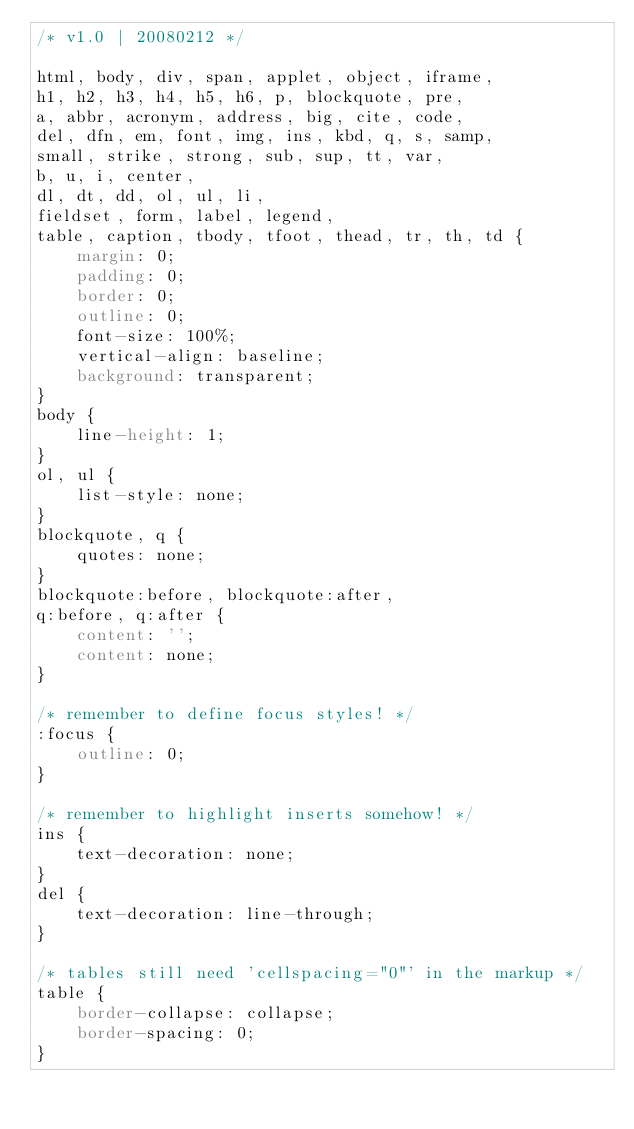Convert code to text. <code><loc_0><loc_0><loc_500><loc_500><_CSS_>/* v1.0 | 20080212 */

html, body, div, span, applet, object, iframe,
h1, h2, h3, h4, h5, h6, p, blockquote, pre,
a, abbr, acronym, address, big, cite, code,
del, dfn, em, font, img, ins, kbd, q, s, samp,
small, strike, strong, sub, sup, tt, var,
b, u, i, center,
dl, dt, dd, ol, ul, li,
fieldset, form, label, legend,
table, caption, tbody, tfoot, thead, tr, th, td {
    margin: 0;
    padding: 0;
    border: 0;
    outline: 0;
    font-size: 100%;
    vertical-align: baseline;
    background: transparent;
}
body {
    line-height: 1;
}
ol, ul {
    list-style: none;
}
blockquote, q {
    quotes: none;
}
blockquote:before, blockquote:after,
q:before, q:after {
    content: '';
    content: none;
}

/* remember to define focus styles! */
:focus {
    outline: 0;
}

/* remember to highlight inserts somehow! */
ins {
    text-decoration: none;
}
del {
    text-decoration: line-through;
}

/* tables still need 'cellspacing="0"' in the markup */
table {
    border-collapse: collapse;
    border-spacing: 0;
}


</code> 